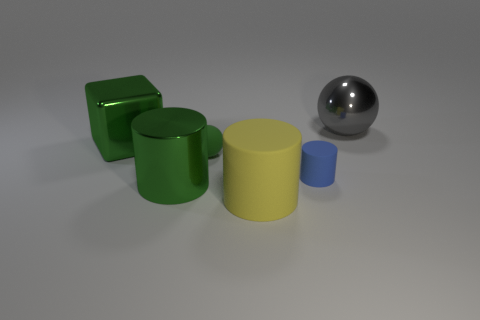Add 2 tiny green rubber things. How many objects exist? 8 Subtract all balls. How many objects are left? 4 Subtract all big blue objects. Subtract all rubber cylinders. How many objects are left? 4 Add 2 matte spheres. How many matte spheres are left? 3 Add 2 large green cubes. How many large green cubes exist? 3 Subtract 1 blue cylinders. How many objects are left? 5 